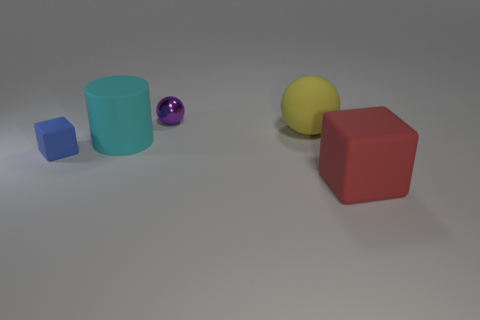Does the thing that is to the right of the rubber sphere have the same material as the tiny purple sphere?
Give a very brief answer. No. There is a big rubber object that is behind the cyan cylinder; does it have the same shape as the tiny metal object behind the large yellow sphere?
Keep it short and to the point. Yes. Is there a large brown object that has the same material as the big block?
Make the answer very short. No. What number of cyan things are either cubes or matte spheres?
Provide a short and direct response. 0. There is a object that is in front of the cyan thing and right of the tiny blue rubber cube; what size is it?
Keep it short and to the point. Large. Is the number of matte objects that are on the left side of the metallic thing greater than the number of cyan cubes?
Offer a very short reply. Yes. What number of balls are either small metallic things or yellow matte objects?
Keep it short and to the point. 2. What shape is the object that is left of the large sphere and on the right side of the cyan cylinder?
Give a very brief answer. Sphere. Are there the same number of large cyan cylinders that are in front of the red rubber thing and cyan rubber objects that are in front of the blue rubber thing?
Your answer should be compact. Yes. How many things are either cyan rubber objects or cyan metallic cubes?
Your answer should be compact. 1. 